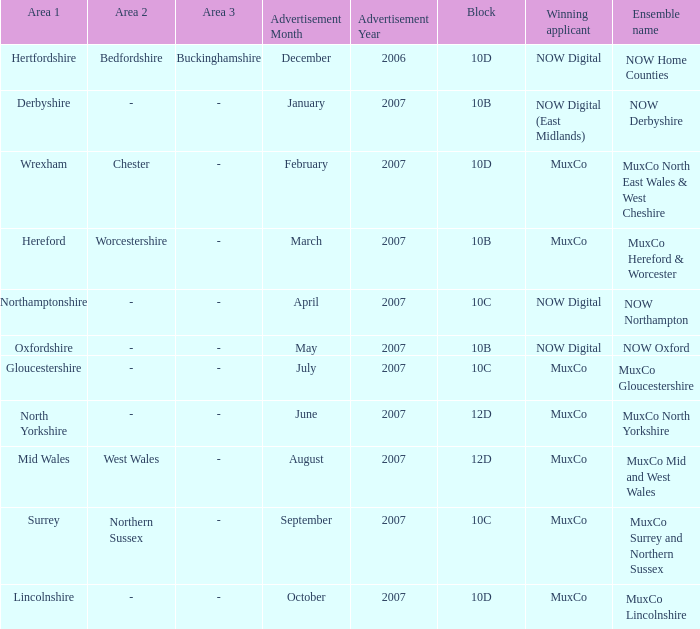Can you provide the name of the ensemble that had an advertisement in october 2007? MuxCo Lincolnshire. 